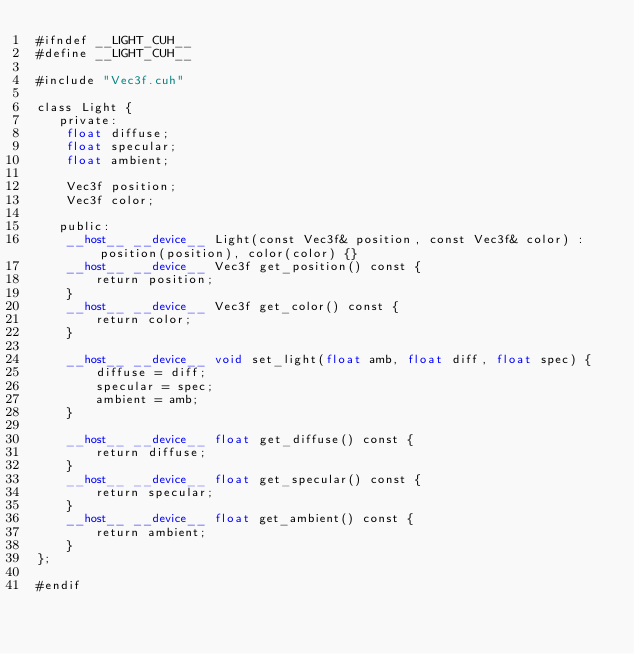Convert code to text. <code><loc_0><loc_0><loc_500><loc_500><_Cuda_>#ifndef __LIGHT_CUH__
#define __LIGHT_CUH__

#include "Vec3f.cuh"

class Light {
   private:
    float diffuse;
    float specular;
    float ambient;

    Vec3f position;
    Vec3f color;

   public:
    __host__ __device__ Light(const Vec3f& position, const Vec3f& color) : position(position), color(color) {}
    __host__ __device__ Vec3f get_position() const { 
        return position; 
    }
    __host__ __device__ Vec3f get_color() const { 
        return color; 
    }

    __host__ __device__ void set_light(float amb, float diff, float spec) {
        diffuse = diff;
        specular = spec;
        ambient = amb;
    }

    __host__ __device__ float get_diffuse() const { 
        return diffuse; 
    }
    __host__ __device__ float get_specular() const { 
        return specular; 
    }
    __host__ __device__ float get_ambient() const { 
        return ambient; 
    }
};

#endif</code> 